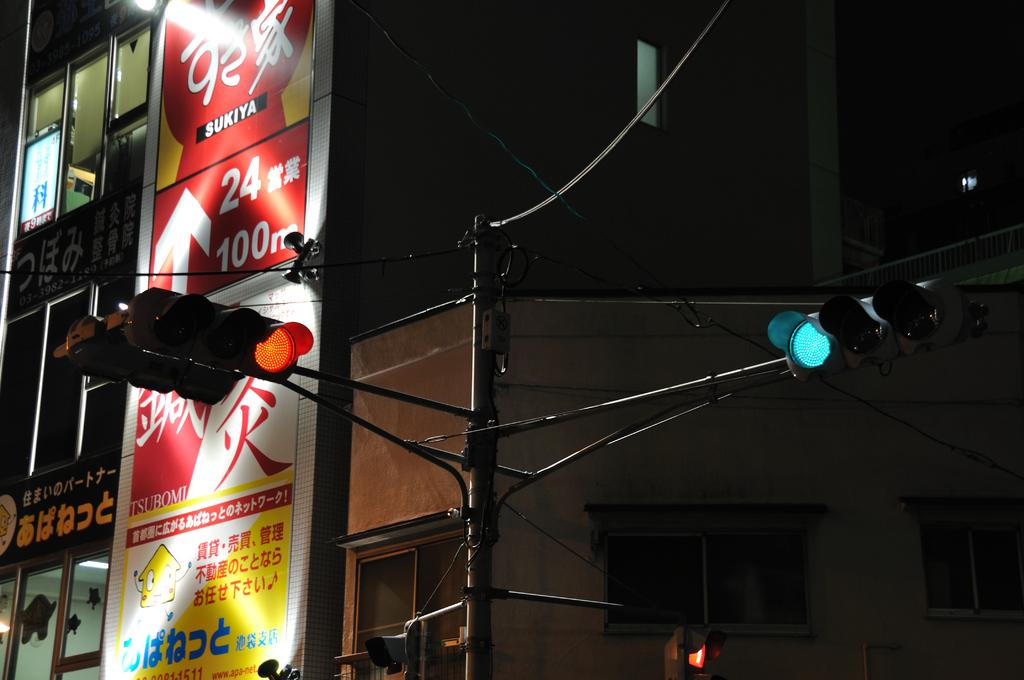What type of structure is visible in the image? There is a building in the image. What is attached to the building? There is a flex banner on the building. What traffic control devices are present in the image? There are traffic lights in the image. How would you describe the lighting conditions in the image? The image appears to be slightly dark. Can you see any pigs flying in the image? No, there are no pigs or any flying objects present in the image. 